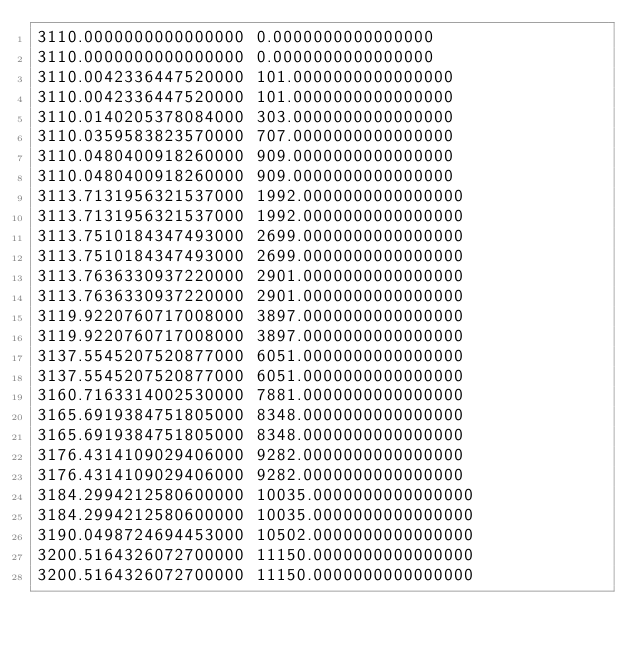<code> <loc_0><loc_0><loc_500><loc_500><_FORTRAN_>3110.0000000000000000 0.0000000000000000
3110.0000000000000000 0.0000000000000000
3110.0042336447520000 101.0000000000000000
3110.0042336447520000 101.0000000000000000
3110.0140205378084000 303.0000000000000000
3110.0359583823570000 707.0000000000000000
3110.0480400918260000 909.0000000000000000
3110.0480400918260000 909.0000000000000000
3113.7131956321537000 1992.0000000000000000
3113.7131956321537000 1992.0000000000000000
3113.7510184347493000 2699.0000000000000000
3113.7510184347493000 2699.0000000000000000
3113.7636330937220000 2901.0000000000000000
3113.7636330937220000 2901.0000000000000000
3119.9220760717008000 3897.0000000000000000
3119.9220760717008000 3897.0000000000000000
3137.5545207520877000 6051.0000000000000000
3137.5545207520877000 6051.0000000000000000
3160.7163314002530000 7881.0000000000000000
3165.6919384751805000 8348.0000000000000000
3165.6919384751805000 8348.0000000000000000
3176.4314109029406000 9282.0000000000000000
3176.4314109029406000 9282.0000000000000000
3184.2994212580600000 10035.0000000000000000
3184.2994212580600000 10035.0000000000000000
3190.0498724694453000 10502.0000000000000000
3200.5164326072700000 11150.0000000000000000
3200.5164326072700000 11150.0000000000000000</code> 